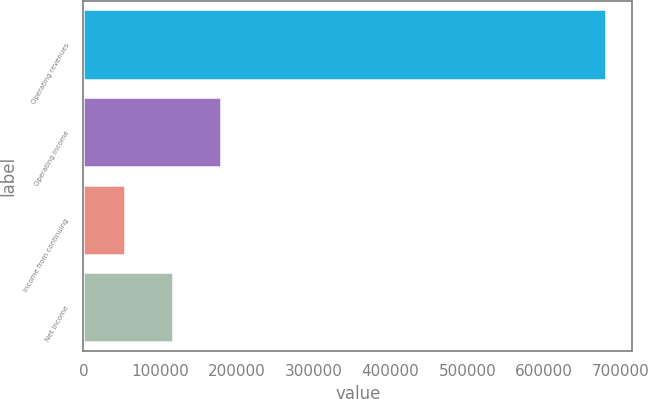<chart> <loc_0><loc_0><loc_500><loc_500><bar_chart><fcel>Operating revenues<fcel>Operating income<fcel>Income from continuing<fcel>Net income<nl><fcel>680913<fcel>179562<fcel>54224<fcel>116893<nl></chart> 